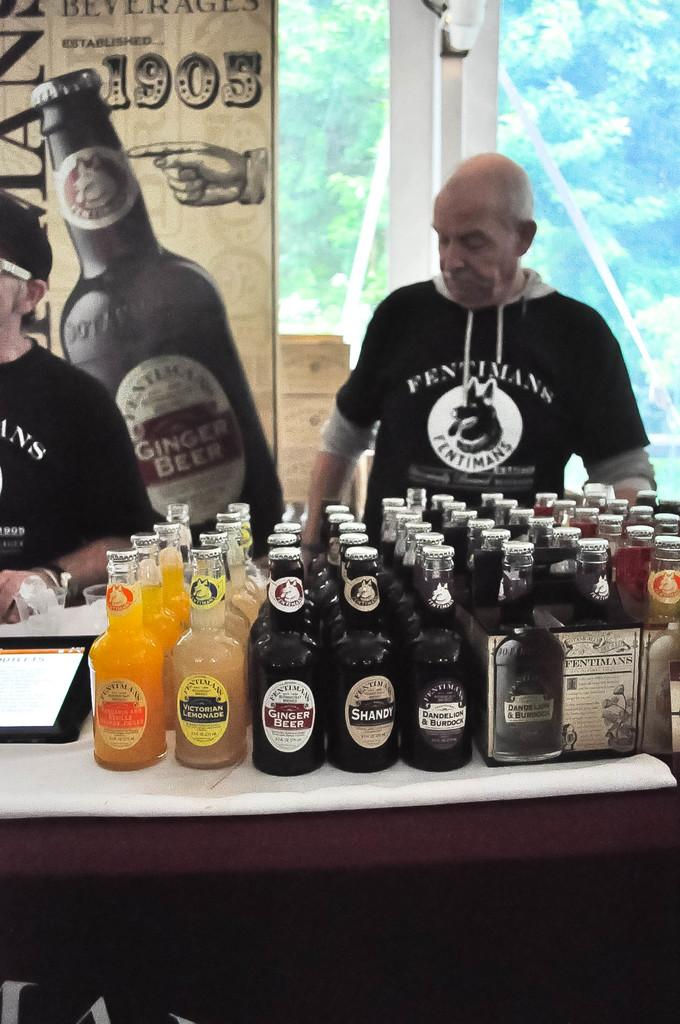<image>
Provide a brief description of the given image. A big sign is hanging in the background with a picture of a big beer bottle and the date of 1905. 